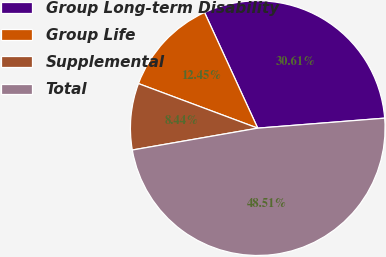<chart> <loc_0><loc_0><loc_500><loc_500><pie_chart><fcel>Group Long-term Disability<fcel>Group Life<fcel>Supplemental<fcel>Total<nl><fcel>30.61%<fcel>12.45%<fcel>8.44%<fcel>48.51%<nl></chart> 